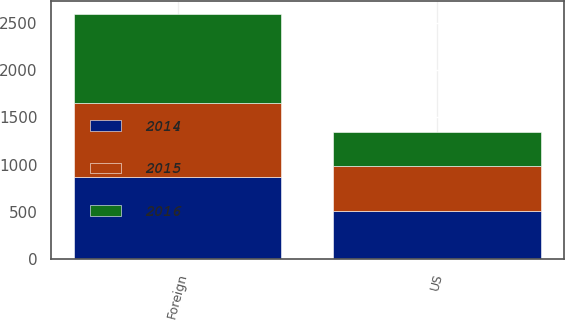Convert chart to OTSL. <chart><loc_0><loc_0><loc_500><loc_500><stacked_bar_chart><ecel><fcel>US<fcel>Foreign<nl><fcel>2016<fcel>366<fcel>952<nl><fcel>2015<fcel>479<fcel>782<nl><fcel>2014<fcel>506<fcel>868<nl></chart> 